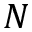Convert formula to latex. <formula><loc_0><loc_0><loc_500><loc_500>N</formula> 